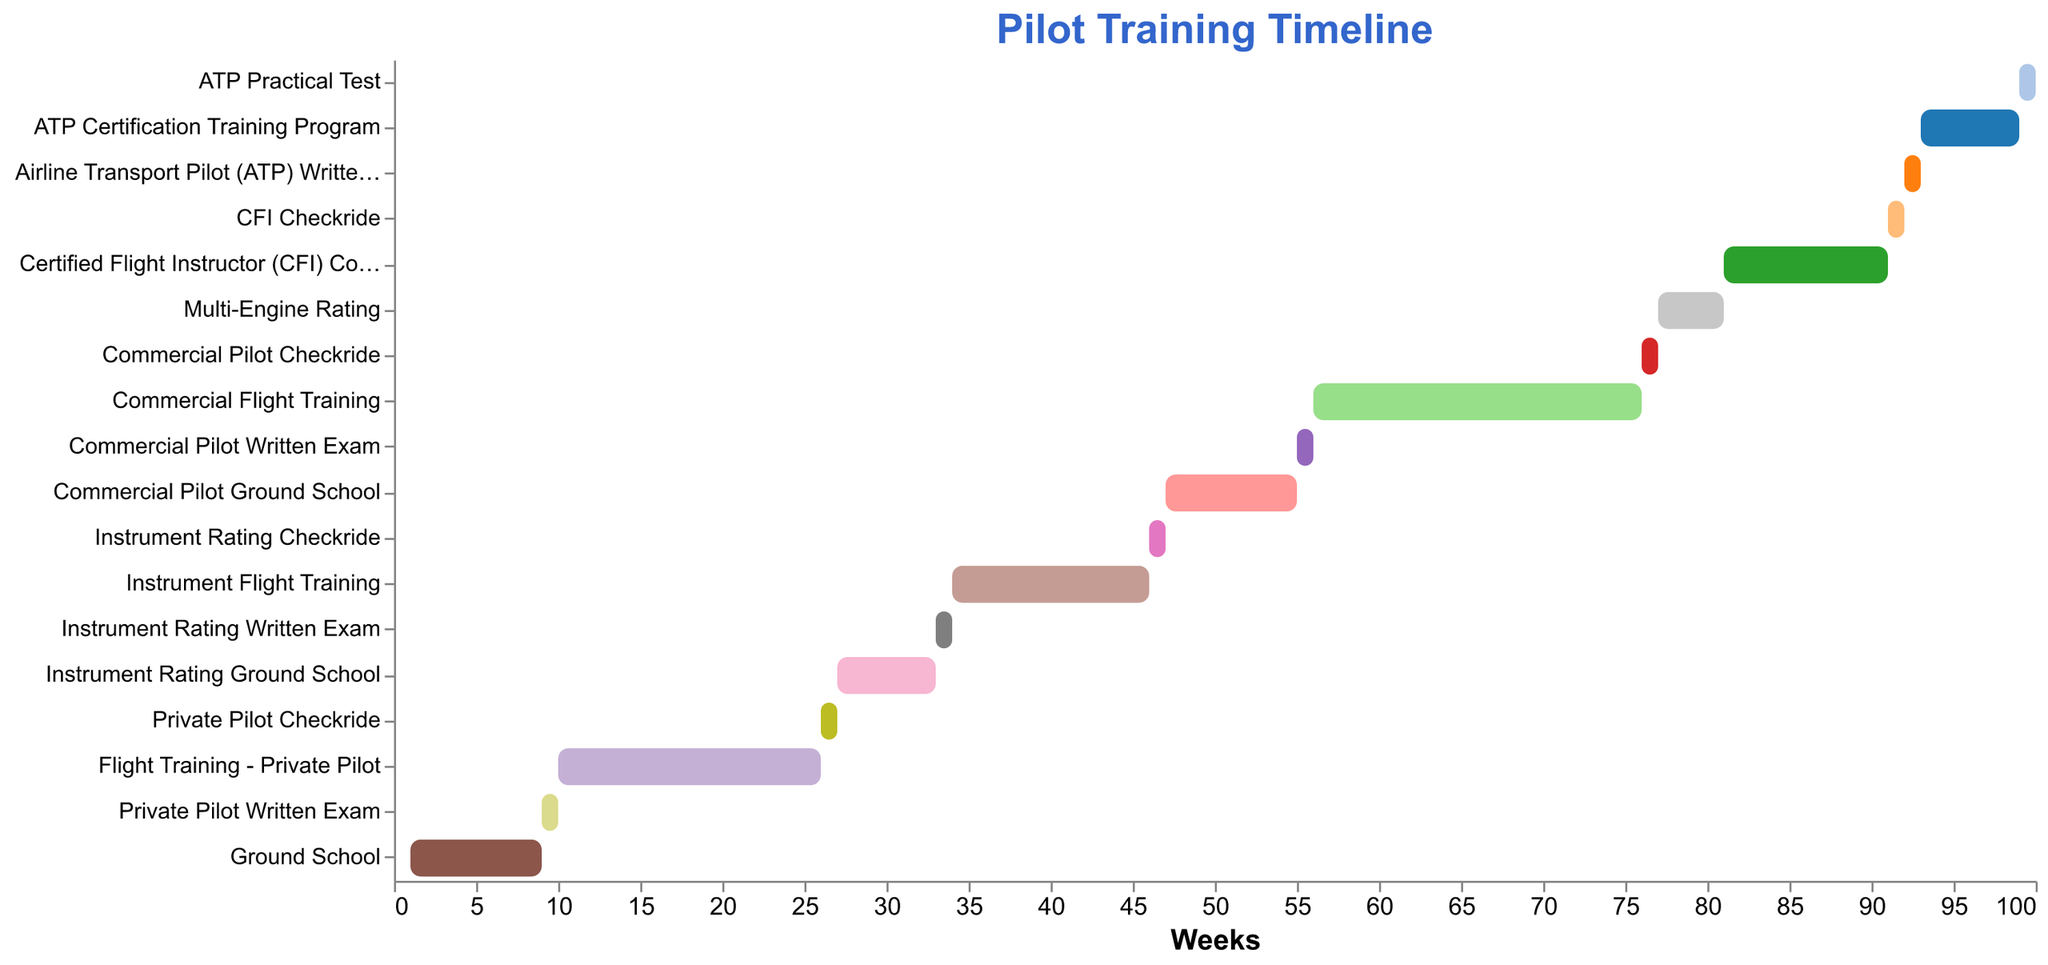What's the total duration of Ground School? Ground School starts at Week 1 and lasts for 8 weeks. Therefore, the total duration is 8 weeks.
Answer: 8 weeks Which task starts immediately after Flight Training - Private Pilot? From the figure, Flight Training - Private Pilot ends at Week 25. The next task starts at Week 26, which is the Private Pilot Checkride.
Answer: Private Pilot Checkride How long is the Commercial Flight Training? According to the figure, the Commercial Flight Training starts at Week 56 and lasts for 20 weeks.
Answer: 20 weeks What's the duration of time between the start of Ground School and the end of the Private Pilot Checkride? Ground School starts at Week 1 and the Private Pilot Checkride ends at Week 26. Therefore, the duration is 26 weeks.
Answer: 26 weeks What is the shortest task in the figure? By examining the duration of each task, the shortest task is the Private Pilot Written Exam, which lasts for 1 week.
Answer: Private Pilot Written Exam How many different tasks involve a checkride? The tasks involving a checkride are Private Pilot Checkride, Instrument Rating Checkride, Commercial Pilot Checkride, and CFI Checkride. There are 4 tasks.
Answer: 4 tasks Which task has the latest start time? By analyzing the start times of the tasks, the ATP Practical Test starts the latest at Week 99.
Answer: ATP Practical Test What is the color used to represent the Airline Transport Pilot (ATP) Written Exam? To determine the color representing the ATP Written Exam, we need to refer to the figure's legend; examining the Vegas Lite schema for colors, the task is colored distinctly (the exact color name can be visually interpreted).
Answer: Not explicitly specified Which task takes the longest duration to complete? Comparing the duration of all tasks, the Commercial Flight Training takes the longest with a duration of 20 weeks.
Answer: Commercial Flight Training 